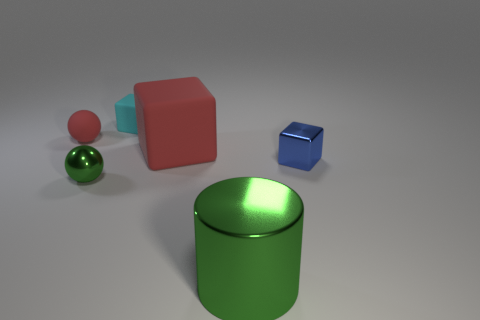Is the color of the rubber object that is to the right of the small cyan rubber block the same as the tiny rubber thing that is in front of the tiny rubber cube?
Provide a short and direct response. Yes. There is a shiny object that is the same color as the large metal cylinder; what size is it?
Your answer should be very brief. Small. What material is the tiny sphere that is the same color as the metal cylinder?
Keep it short and to the point. Metal. What number of large objects are cyan matte cubes or green spheres?
Offer a terse response. 0. There is a tiny thing that is in front of the small blue metal cube; what shape is it?
Make the answer very short. Sphere. Is there a metal object that has the same color as the big metallic cylinder?
Keep it short and to the point. Yes. Do the metal object left of the large green shiny cylinder and the ball behind the small blue block have the same size?
Your response must be concise. Yes. Are there more big rubber blocks that are left of the blue block than small shiny things in front of the large green thing?
Your response must be concise. Yes. Is there a cube made of the same material as the big cylinder?
Provide a short and direct response. Yes. Does the matte sphere have the same color as the large rubber object?
Ensure brevity in your answer.  Yes. 